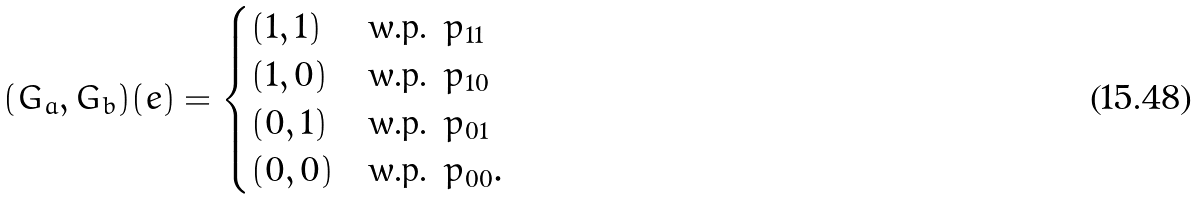<formula> <loc_0><loc_0><loc_500><loc_500>( G _ { a } , G _ { b } ) ( e ) = \begin{cases} ( 1 , 1 ) & \text {w.p. } p _ { 1 1 } \\ ( 1 , 0 ) & \text {w.p. } p _ { 1 0 } \\ ( 0 , 1 ) & \text {w.p. } p _ { 0 1 } \\ ( 0 , 0 ) & \text {w.p. } p _ { 0 0 } . \end{cases}</formula> 